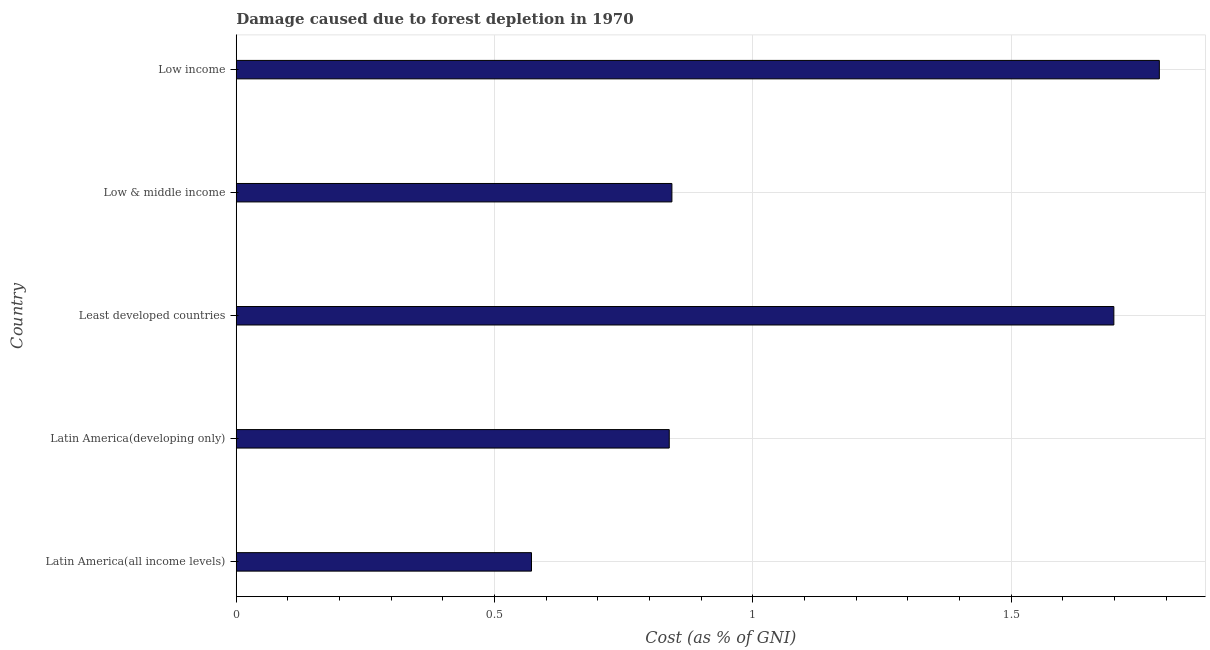Does the graph contain grids?
Your response must be concise. Yes. What is the title of the graph?
Make the answer very short. Damage caused due to forest depletion in 1970. What is the label or title of the X-axis?
Your answer should be compact. Cost (as % of GNI). What is the damage caused due to forest depletion in Low & middle income?
Make the answer very short. 0.84. Across all countries, what is the maximum damage caused due to forest depletion?
Keep it short and to the point. 1.79. Across all countries, what is the minimum damage caused due to forest depletion?
Ensure brevity in your answer.  0.57. In which country was the damage caused due to forest depletion maximum?
Offer a terse response. Low income. In which country was the damage caused due to forest depletion minimum?
Your answer should be very brief. Latin America(all income levels). What is the sum of the damage caused due to forest depletion?
Your response must be concise. 5.74. What is the difference between the damage caused due to forest depletion in Least developed countries and Low income?
Provide a short and direct response. -0.09. What is the average damage caused due to forest depletion per country?
Give a very brief answer. 1.15. What is the median damage caused due to forest depletion?
Provide a succinct answer. 0.84. In how many countries, is the damage caused due to forest depletion greater than 0.4 %?
Make the answer very short. 5. What is the ratio of the damage caused due to forest depletion in Least developed countries to that in Low income?
Make the answer very short. 0.95. What is the difference between the highest and the second highest damage caused due to forest depletion?
Ensure brevity in your answer.  0.09. Is the sum of the damage caused due to forest depletion in Latin America(all income levels) and Low income greater than the maximum damage caused due to forest depletion across all countries?
Your answer should be very brief. Yes. What is the difference between the highest and the lowest damage caused due to forest depletion?
Your answer should be compact. 1.22. In how many countries, is the damage caused due to forest depletion greater than the average damage caused due to forest depletion taken over all countries?
Give a very brief answer. 2. Are all the bars in the graph horizontal?
Keep it short and to the point. Yes. How many countries are there in the graph?
Your answer should be compact. 5. What is the difference between two consecutive major ticks on the X-axis?
Give a very brief answer. 0.5. Are the values on the major ticks of X-axis written in scientific E-notation?
Offer a very short reply. No. What is the Cost (as % of GNI) of Latin America(all income levels)?
Provide a short and direct response. 0.57. What is the Cost (as % of GNI) of Latin America(developing only)?
Offer a very short reply. 0.84. What is the Cost (as % of GNI) in Least developed countries?
Make the answer very short. 1.7. What is the Cost (as % of GNI) of Low & middle income?
Offer a terse response. 0.84. What is the Cost (as % of GNI) of Low income?
Offer a very short reply. 1.79. What is the difference between the Cost (as % of GNI) in Latin America(all income levels) and Latin America(developing only)?
Offer a terse response. -0.27. What is the difference between the Cost (as % of GNI) in Latin America(all income levels) and Least developed countries?
Make the answer very short. -1.13. What is the difference between the Cost (as % of GNI) in Latin America(all income levels) and Low & middle income?
Your answer should be very brief. -0.27. What is the difference between the Cost (as % of GNI) in Latin America(all income levels) and Low income?
Keep it short and to the point. -1.22. What is the difference between the Cost (as % of GNI) in Latin America(developing only) and Least developed countries?
Your answer should be very brief. -0.86. What is the difference between the Cost (as % of GNI) in Latin America(developing only) and Low & middle income?
Offer a very short reply. -0.01. What is the difference between the Cost (as % of GNI) in Latin America(developing only) and Low income?
Ensure brevity in your answer.  -0.95. What is the difference between the Cost (as % of GNI) in Least developed countries and Low & middle income?
Offer a terse response. 0.86. What is the difference between the Cost (as % of GNI) in Least developed countries and Low income?
Offer a terse response. -0.09. What is the difference between the Cost (as % of GNI) in Low & middle income and Low income?
Provide a succinct answer. -0.94. What is the ratio of the Cost (as % of GNI) in Latin America(all income levels) to that in Latin America(developing only)?
Your answer should be compact. 0.68. What is the ratio of the Cost (as % of GNI) in Latin America(all income levels) to that in Least developed countries?
Your answer should be very brief. 0.34. What is the ratio of the Cost (as % of GNI) in Latin America(all income levels) to that in Low & middle income?
Keep it short and to the point. 0.68. What is the ratio of the Cost (as % of GNI) in Latin America(all income levels) to that in Low income?
Offer a very short reply. 0.32. What is the ratio of the Cost (as % of GNI) in Latin America(developing only) to that in Least developed countries?
Make the answer very short. 0.49. What is the ratio of the Cost (as % of GNI) in Latin America(developing only) to that in Low & middle income?
Your answer should be compact. 0.99. What is the ratio of the Cost (as % of GNI) in Latin America(developing only) to that in Low income?
Ensure brevity in your answer.  0.47. What is the ratio of the Cost (as % of GNI) in Least developed countries to that in Low & middle income?
Offer a terse response. 2.01. What is the ratio of the Cost (as % of GNI) in Least developed countries to that in Low income?
Your answer should be very brief. 0.95. What is the ratio of the Cost (as % of GNI) in Low & middle income to that in Low income?
Your answer should be compact. 0.47. 